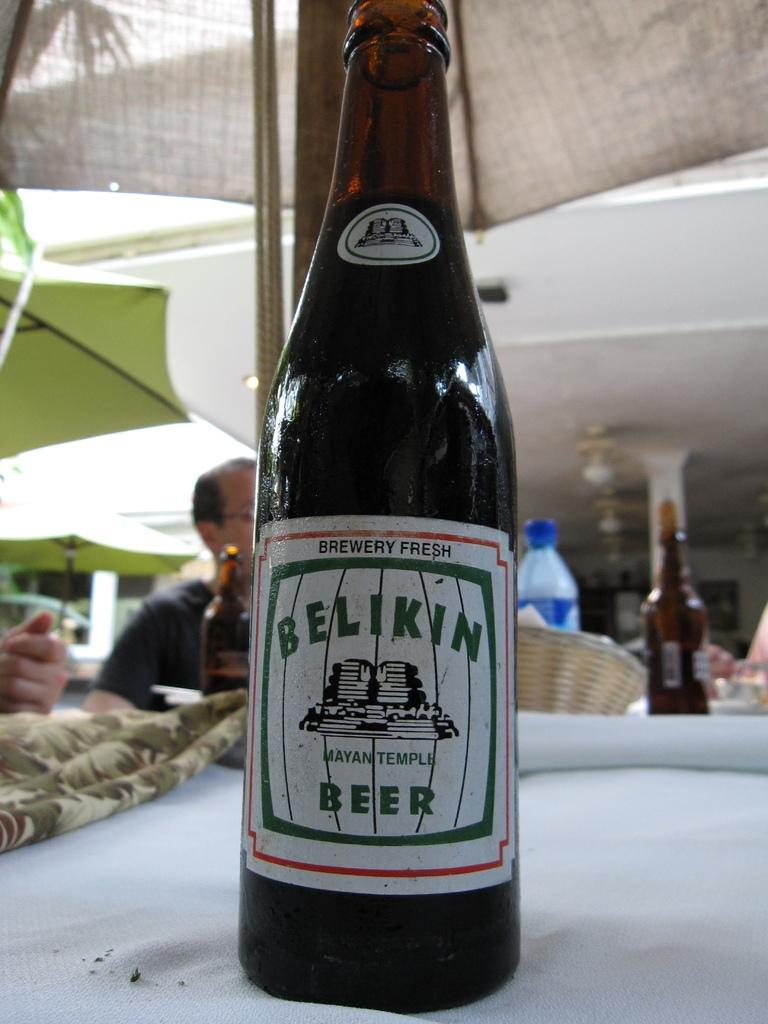Provide a one-sentence caption for the provided image. A bottle has the brand name Belikin on it. 